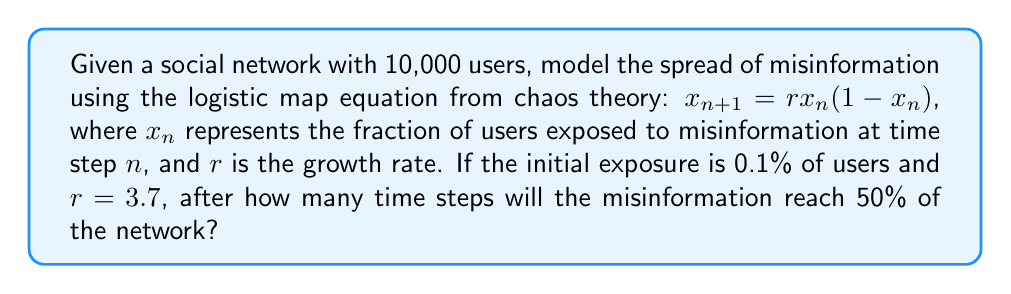Can you answer this question? Let's approach this step-by-step:

1) The logistic map equation is given by:
   $$x_{n+1} = rx_n(1-x_n)$$

2) We're given:
   - Initial exposure $x_0 = 0.001$ (0.1% of 10,000 users)
   - Growth rate $r = 3.7$
   - Target exposure: 50% or 0.5

3) We need to iterate the equation until $x_n \geq 0.5$:

   Step 1: $x_1 = 3.7 * 0.001 * (1-0.001) = 0.003696$
   Step 2: $x_2 = 3.7 * 0.003696 * (1-0.003696) = 0.013624$
   Step 3: $x_3 = 3.7 * 0.013624 * (1-0.013624) = 0.049676$
   Step 4: $x_4 = 3.7 * 0.049676 * (1-0.049676) = 0.174635$
   Step 5: $x_5 = 3.7 * 0.174635 * (1-0.174635) = 0.532595$

4) After 5 iterations, the exposure exceeds 50%.

This demonstrates the butterfly effect in action: a small initial condition (0.1% exposure) leads to a significant impact (over 50% exposure) in just a few steps.
Answer: 5 time steps 